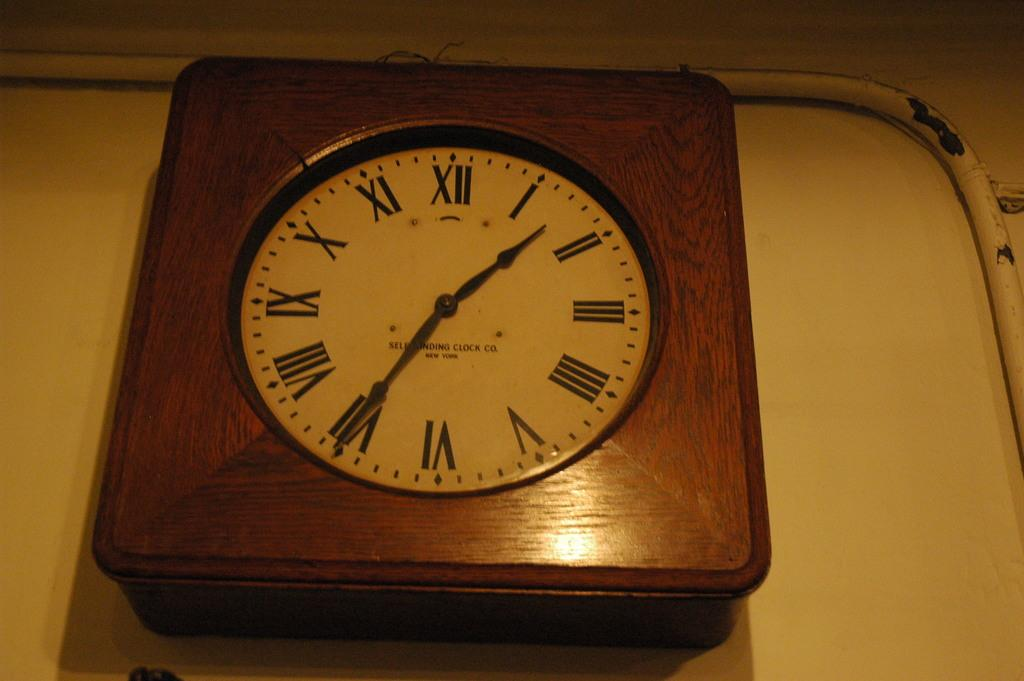<image>
Present a compact description of the photo's key features. A wall clock showing 1:35 as the time. 